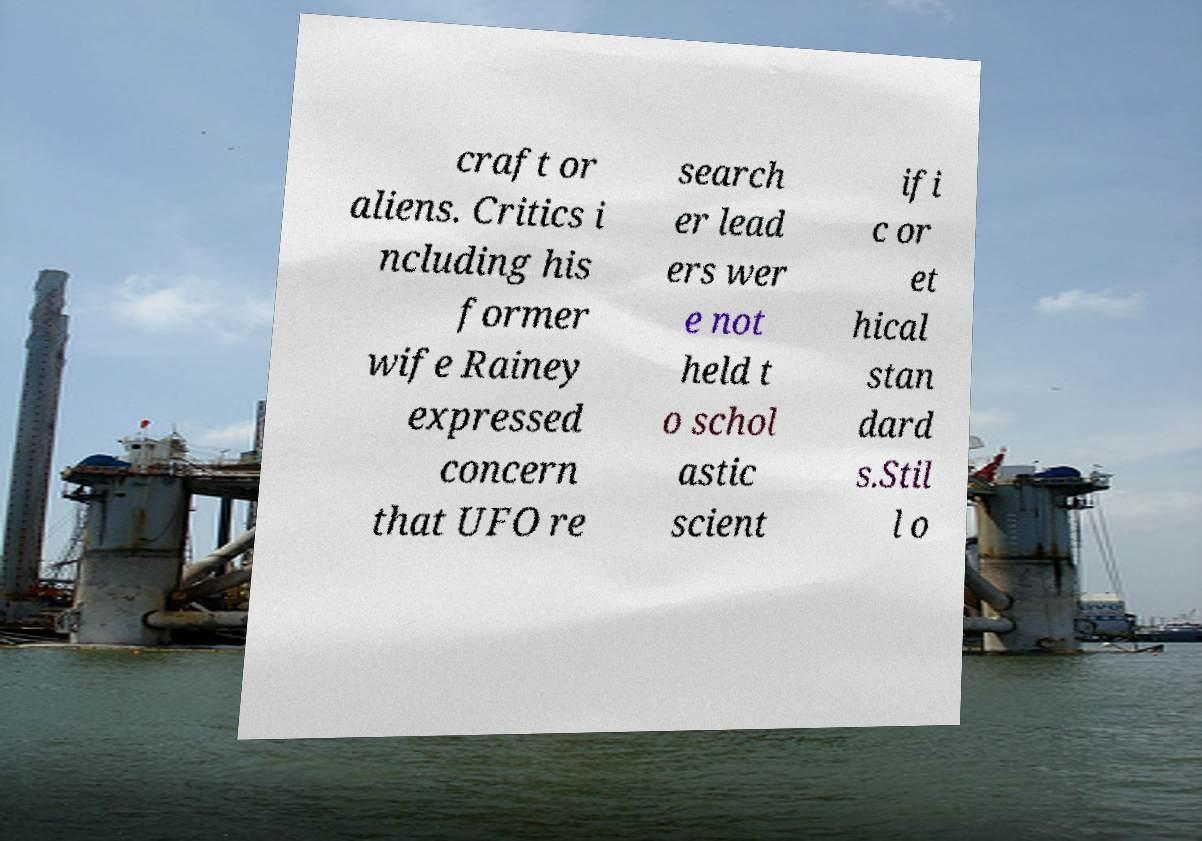Can you read and provide the text displayed in the image?This photo seems to have some interesting text. Can you extract and type it out for me? craft or aliens. Critics i ncluding his former wife Rainey expressed concern that UFO re search er lead ers wer e not held t o schol astic scient ifi c or et hical stan dard s.Stil l o 